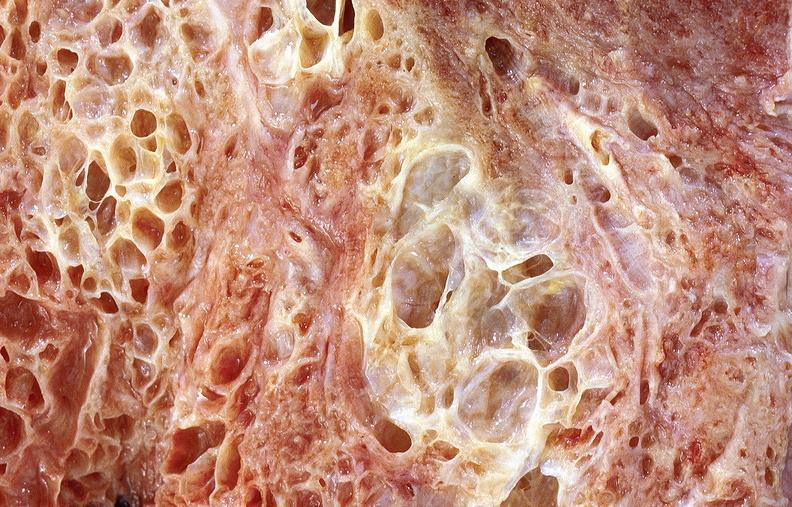where is this?
Answer the question using a single word or phrase. Lung 